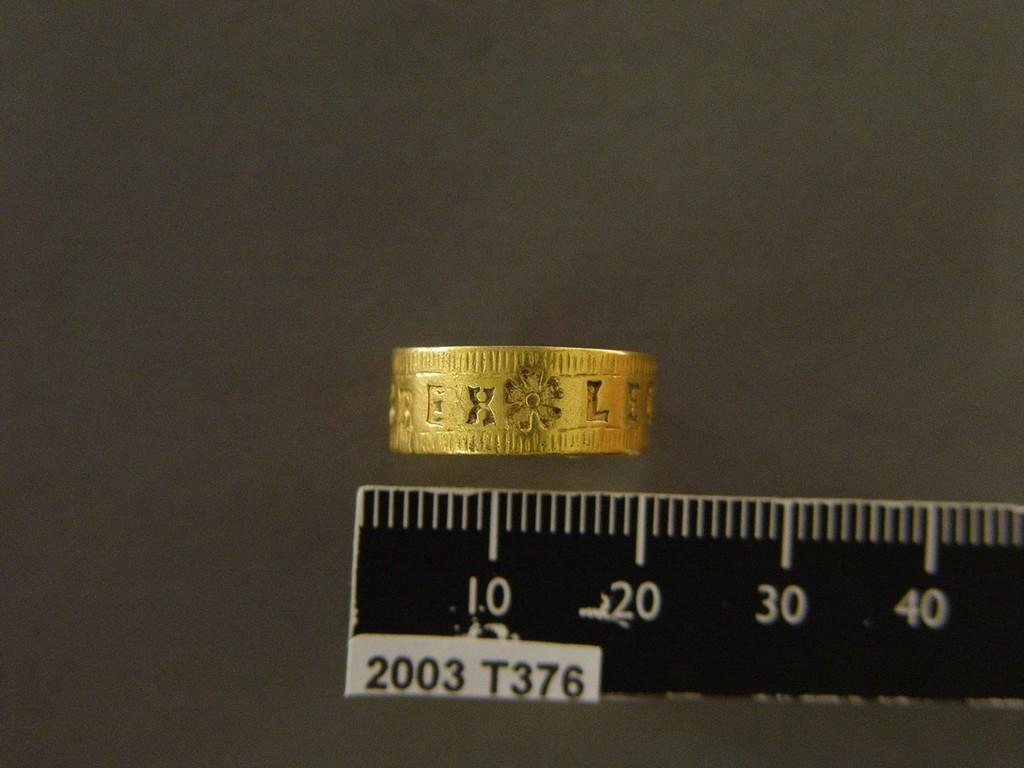<image>
Provide a brief description of the given image. A golden to on top of a black ruler with the numbers 10, 20, 30 and 40. 